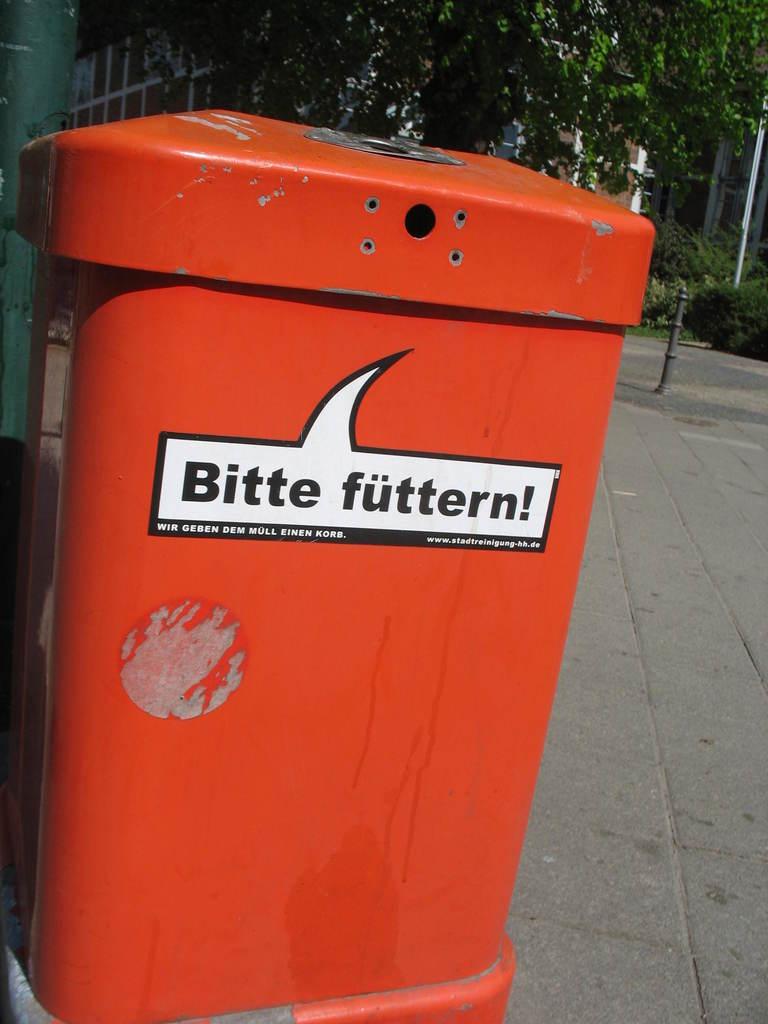What is this red thing supposedly saying in a foreign language?
Your response must be concise. Bitte futtern. 